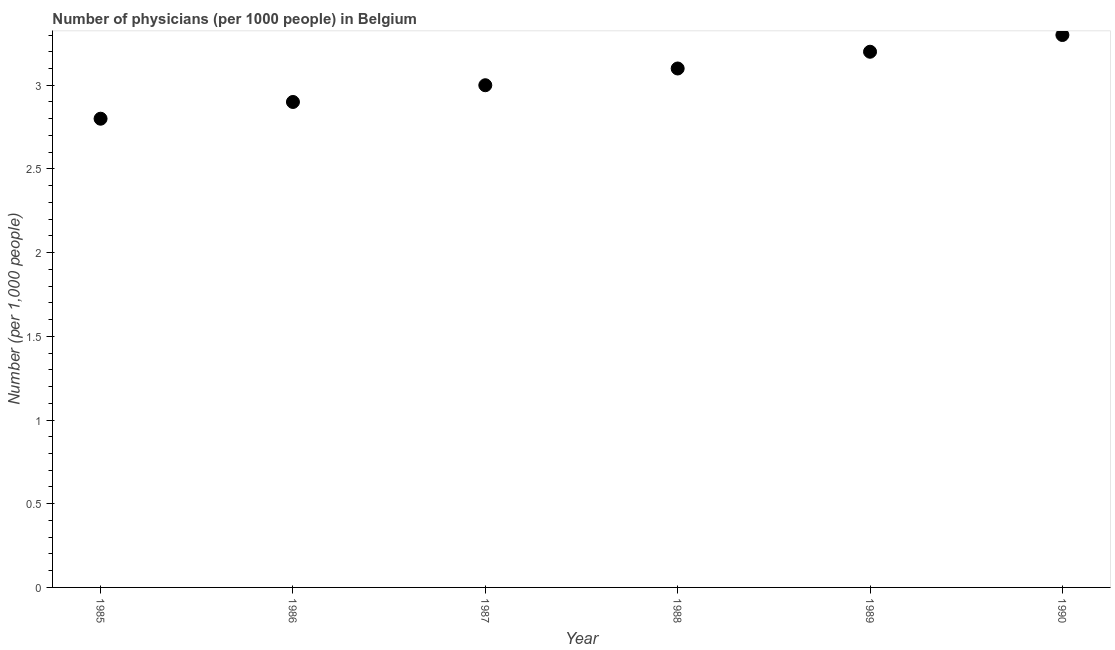What is the number of physicians in 1990?
Offer a very short reply. 3.3. Across all years, what is the maximum number of physicians?
Ensure brevity in your answer.  3.3. Across all years, what is the minimum number of physicians?
Offer a very short reply. 2.8. What is the difference between the number of physicians in 1988 and 1990?
Offer a terse response. -0.2. What is the average number of physicians per year?
Provide a succinct answer. 3.05. What is the median number of physicians?
Offer a terse response. 3.05. In how many years, is the number of physicians greater than 0.2 ?
Keep it short and to the point. 6. Do a majority of the years between 1988 and 1989 (inclusive) have number of physicians greater than 0.6 ?
Your answer should be compact. Yes. What is the ratio of the number of physicians in 1985 to that in 1989?
Your response must be concise. 0.87. Is the number of physicians in 1985 less than that in 1989?
Provide a succinct answer. Yes. Is the difference between the number of physicians in 1986 and 1988 greater than the difference between any two years?
Keep it short and to the point. No. What is the difference between the highest and the second highest number of physicians?
Provide a short and direct response. 0.1. What is the difference between the highest and the lowest number of physicians?
Your answer should be compact. 0.5. Does the number of physicians monotonically increase over the years?
Provide a succinct answer. Yes. How many dotlines are there?
Offer a terse response. 1. What is the difference between two consecutive major ticks on the Y-axis?
Your answer should be compact. 0.5. Does the graph contain any zero values?
Offer a very short reply. No. What is the title of the graph?
Offer a very short reply. Number of physicians (per 1000 people) in Belgium. What is the label or title of the Y-axis?
Your answer should be compact. Number (per 1,0 people). What is the Number (per 1,000 people) in 1985?
Your response must be concise. 2.8. What is the Number (per 1,000 people) in 1990?
Provide a succinct answer. 3.3. What is the difference between the Number (per 1,000 people) in 1985 and 1988?
Ensure brevity in your answer.  -0.3. What is the difference between the Number (per 1,000 people) in 1985 and 1989?
Your response must be concise. -0.4. What is the difference between the Number (per 1,000 people) in 1985 and 1990?
Make the answer very short. -0.5. What is the difference between the Number (per 1,000 people) in 1986 and 1988?
Make the answer very short. -0.2. What is the difference between the Number (per 1,000 people) in 1986 and 1990?
Keep it short and to the point. -0.4. What is the difference between the Number (per 1,000 people) in 1987 and 1988?
Your answer should be compact. -0.1. What is the difference between the Number (per 1,000 people) in 1987 and 1989?
Keep it short and to the point. -0.2. What is the difference between the Number (per 1,000 people) in 1987 and 1990?
Keep it short and to the point. -0.3. What is the difference between the Number (per 1,000 people) in 1988 and 1989?
Keep it short and to the point. -0.1. What is the difference between the Number (per 1,000 people) in 1989 and 1990?
Your answer should be very brief. -0.1. What is the ratio of the Number (per 1,000 people) in 1985 to that in 1986?
Offer a terse response. 0.97. What is the ratio of the Number (per 1,000 people) in 1985 to that in 1987?
Ensure brevity in your answer.  0.93. What is the ratio of the Number (per 1,000 people) in 1985 to that in 1988?
Provide a short and direct response. 0.9. What is the ratio of the Number (per 1,000 people) in 1985 to that in 1990?
Your response must be concise. 0.85. What is the ratio of the Number (per 1,000 people) in 1986 to that in 1987?
Your answer should be compact. 0.97. What is the ratio of the Number (per 1,000 people) in 1986 to that in 1988?
Make the answer very short. 0.94. What is the ratio of the Number (per 1,000 people) in 1986 to that in 1989?
Offer a terse response. 0.91. What is the ratio of the Number (per 1,000 people) in 1986 to that in 1990?
Give a very brief answer. 0.88. What is the ratio of the Number (per 1,000 people) in 1987 to that in 1988?
Your response must be concise. 0.97. What is the ratio of the Number (per 1,000 people) in 1987 to that in 1989?
Provide a succinct answer. 0.94. What is the ratio of the Number (per 1,000 people) in 1987 to that in 1990?
Offer a very short reply. 0.91. What is the ratio of the Number (per 1,000 people) in 1988 to that in 1990?
Give a very brief answer. 0.94. What is the ratio of the Number (per 1,000 people) in 1989 to that in 1990?
Make the answer very short. 0.97. 